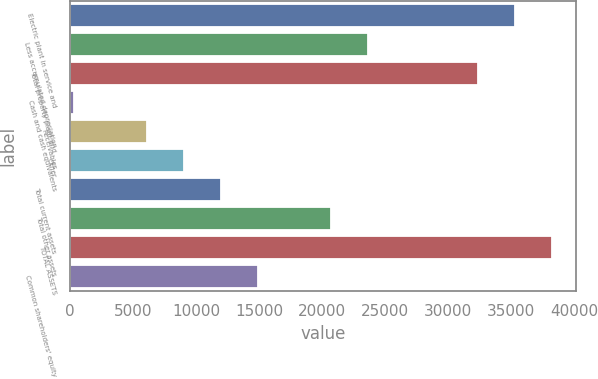<chart> <loc_0><loc_0><loc_500><loc_500><bar_chart><fcel>Electric plant in service and<fcel>Less accumulated depreciation<fcel>Total property plant and<fcel>Cash and cash equivalents<fcel>Receivables<fcel>Other<fcel>Total current assets<fcel>Total other assets<fcel>TOTAL ASSETS<fcel>Common shareholders' equity<nl><fcel>35346.2<fcel>23659.8<fcel>32424.6<fcel>287<fcel>6130.2<fcel>9051.8<fcel>11973.4<fcel>20738.2<fcel>38267.8<fcel>14895<nl></chart> 